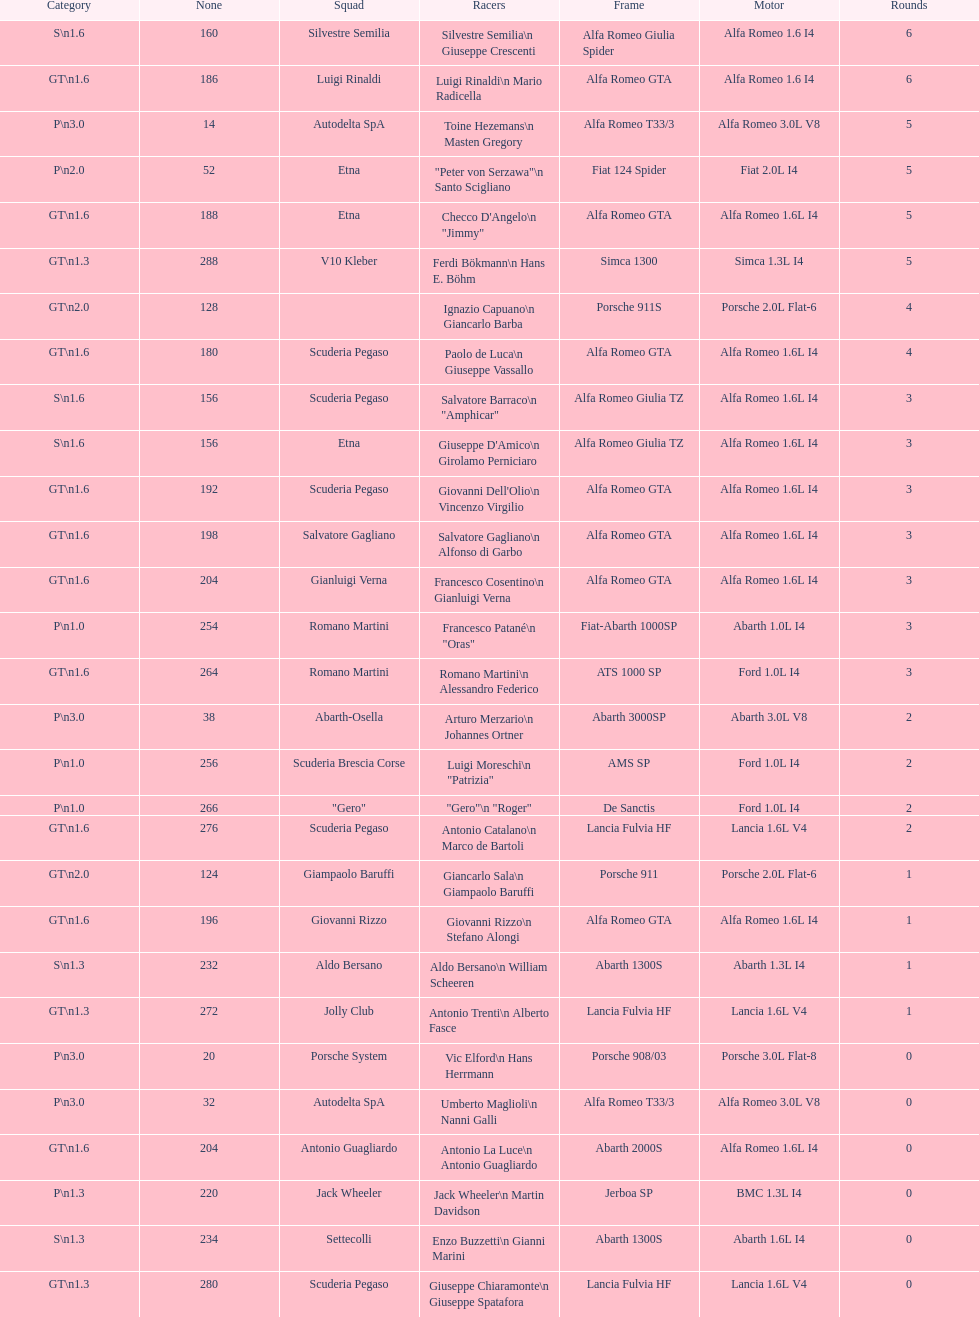How many teams failed to finish the race after 2 laps? 4. 